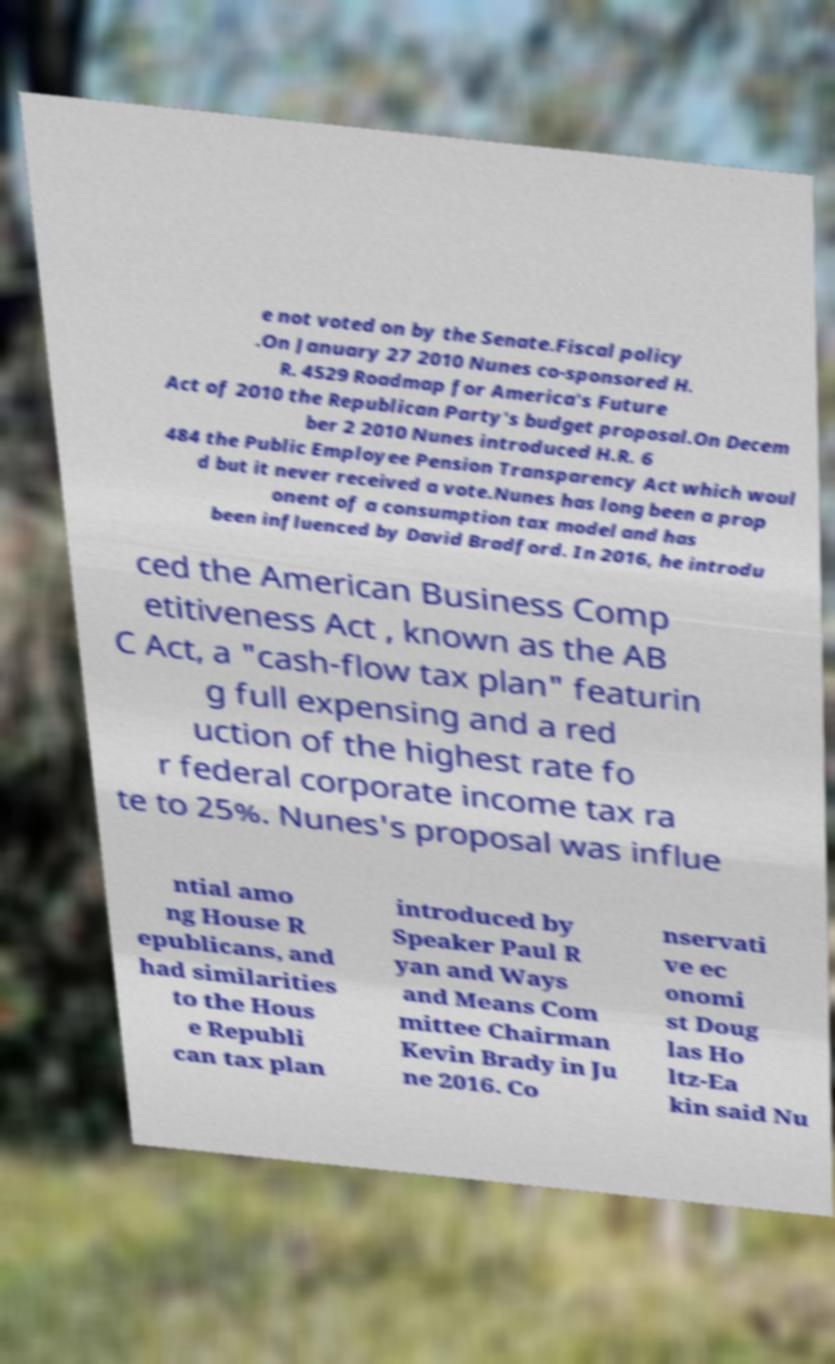Could you assist in decoding the text presented in this image and type it out clearly? e not voted on by the Senate.Fiscal policy .On January 27 2010 Nunes co-sponsored H. R. 4529 Roadmap for America's Future Act of 2010 the Republican Party's budget proposal.On Decem ber 2 2010 Nunes introduced H.R. 6 484 the Public Employee Pension Transparency Act which woul d but it never received a vote.Nunes has long been a prop onent of a consumption tax model and has been influenced by David Bradford. In 2016, he introdu ced the American Business Comp etitiveness Act , known as the AB C Act, a "cash-flow tax plan" featurin g full expensing and a red uction of the highest rate fo r federal corporate income tax ra te to 25%. Nunes's proposal was influe ntial amo ng House R epublicans, and had similarities to the Hous e Republi can tax plan introduced by Speaker Paul R yan and Ways and Means Com mittee Chairman Kevin Brady in Ju ne 2016. Co nservati ve ec onomi st Doug las Ho ltz-Ea kin said Nu 